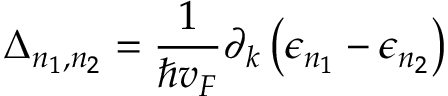Convert formula to latex. <formula><loc_0><loc_0><loc_500><loc_500>\Delta _ { n _ { 1 } , n _ { 2 } } = \frac { 1 } { \hbar { v } _ { F } } \partial _ { k } \left ( \epsilon _ { n _ { 1 } } - \epsilon _ { n _ { 2 } } \right )</formula> 